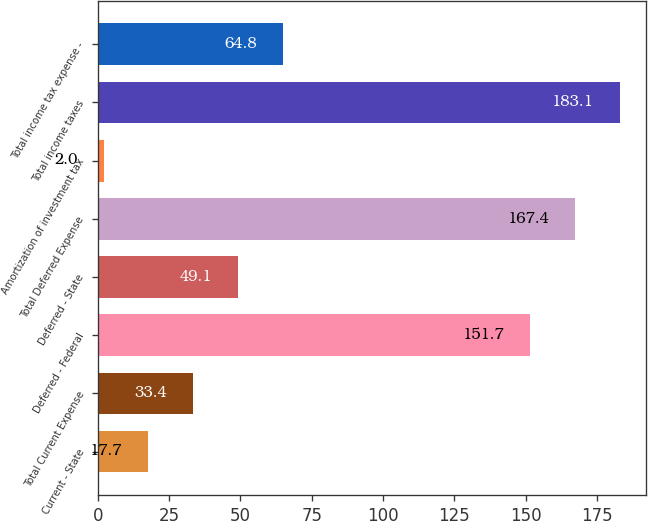<chart> <loc_0><loc_0><loc_500><loc_500><bar_chart><fcel>Current - State<fcel>Total Current Expense<fcel>Deferred - Federal<fcel>Deferred - State<fcel>Total Deferred Expense<fcel>Amortization of investment tax<fcel>Total income taxes<fcel>Total income tax expense -<nl><fcel>17.7<fcel>33.4<fcel>151.7<fcel>49.1<fcel>167.4<fcel>2<fcel>183.1<fcel>64.8<nl></chart> 